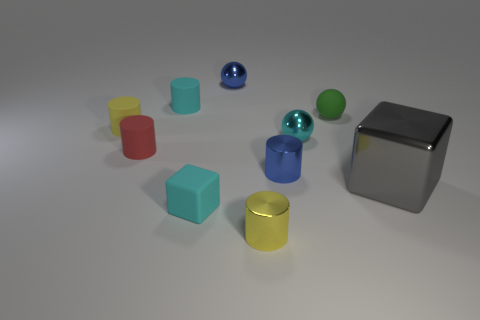There is a small blue thing on the right side of the yellow cylinder that is right of the blue thing that is behind the tiny green rubber sphere; what is its shape?
Offer a terse response. Cylinder. Are there the same number of small metallic cylinders that are behind the small cyan block and small blue balls?
Your answer should be compact. Yes. Do the red object and the gray shiny object have the same size?
Your answer should be very brief. No. How many metal things are spheres or small brown cylinders?
Your answer should be very brief. 2. There is a blue cylinder that is the same size as the cyan shiny ball; what is its material?
Provide a succinct answer. Metal. What number of other things are there of the same material as the green sphere
Your response must be concise. 4. Are there fewer cyan cubes that are behind the tiny green object than small brown shiny cylinders?
Give a very brief answer. No. Is the large gray thing the same shape as the yellow rubber thing?
Provide a succinct answer. No. What size is the gray thing that is on the right side of the tiny cyan rubber object that is behind the tiny yellow cylinder behind the large gray thing?
Keep it short and to the point. Large. There is a tiny blue object that is the same shape as the tiny cyan metal thing; what is it made of?
Provide a succinct answer. Metal. 